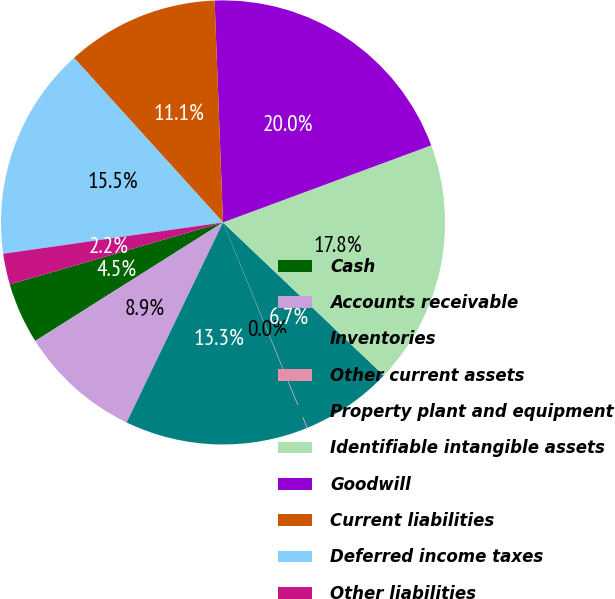<chart> <loc_0><loc_0><loc_500><loc_500><pie_chart><fcel>Cash<fcel>Accounts receivable<fcel>Inventories<fcel>Other current assets<fcel>Property plant and equipment<fcel>Identifiable intangible assets<fcel>Goodwill<fcel>Current liabilities<fcel>Deferred income taxes<fcel>Other liabilities<nl><fcel>4.46%<fcel>8.89%<fcel>13.32%<fcel>0.04%<fcel>6.68%<fcel>17.75%<fcel>19.96%<fcel>11.11%<fcel>15.54%<fcel>2.25%<nl></chart> 